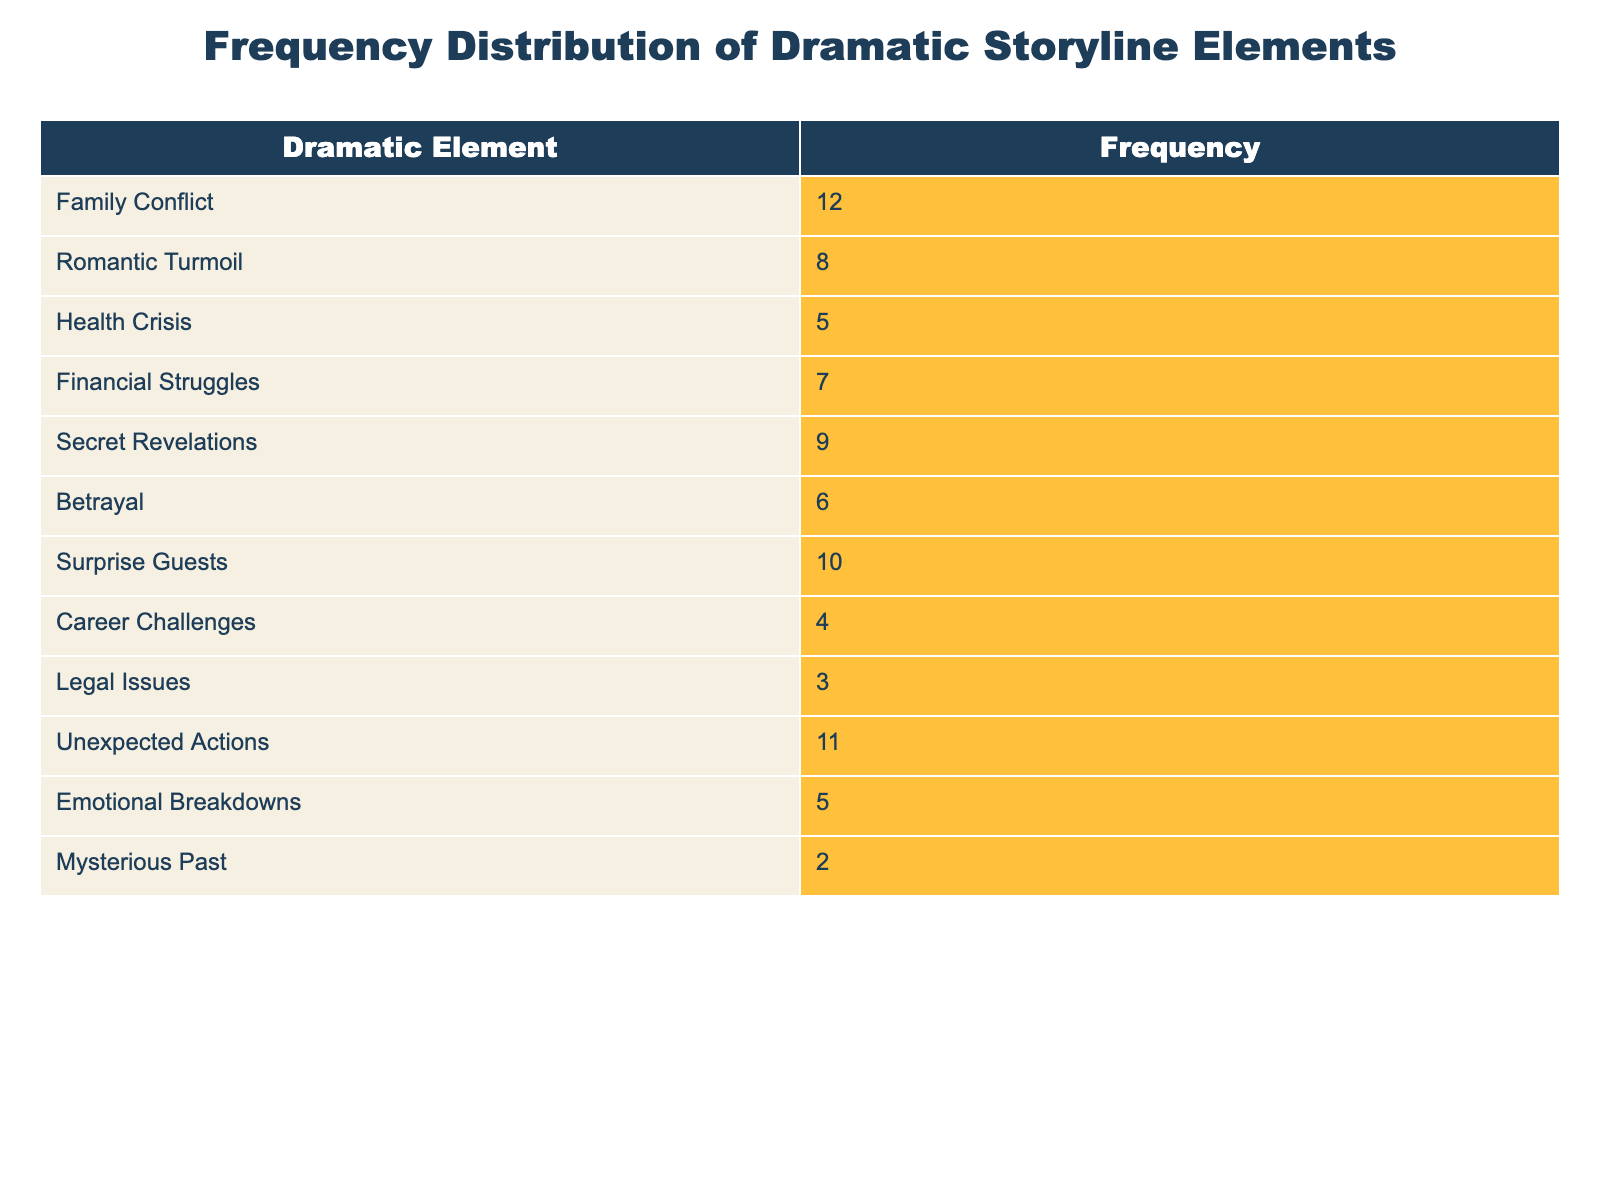What is the frequency of Family Conflict? It is directly mentioned in the table under the Dramatic Element 'Family Conflict', which shows a frequency of 12.
Answer: 12 What is the total frequency of Romantic Turmoil and Health Crisis? The frequency of Romantic Turmoil is 8 and the frequency of Health Crisis is 5. Adding them together gives us 8 + 5 = 13.
Answer: 13 Is the frequency of Legal Issues greater than that of Career Challenges? The table shows that the frequency of Legal Issues is 3 and the frequency of Career Challenges is 4. Since 3 is less than 4, the answer is no.
Answer: No Which dramatic element has the highest frequency? By reviewing the frequencies listed, Family Conflict has the highest frequency of 12 compared to the other elements.
Answer: Family Conflict What is the average frequency of all dramatic elements? To find the average, sum all the frequencies: 12 + 8 + 5 + 7 + 9 + 6 + 10 + 4 + 3 + 11 + 5 + 2 = 82. There are 12 elements, so we divide 82 by 12, which gives us approximately 6.83.
Answer: 6.83 How many dramatic elements have a frequency of 6 or higher? The elements with frequencies of 6 or higher are Family Conflict (12), Surprise Guests (10), Unexpected Actions (11), Secret Revelations (9), Romantic Turmoil (8), and Financial Struggles (7). Counting these gives us a total of 6 elements.
Answer: 6 What is the difference in frequency between the element with the highest and the element with the lowest frequency? The highest frequency is Family Conflict with 12, and the lowest frequency is Mysterious Past with 2. The difference is 12 - 2 = 10.
Answer: 10 Is there a greater frequency of Emotional Breakdowns or Financial Struggles? Emotional Breakdowns has a frequency of 5, while Financial Struggles has a frequency of 7. Since 5 is less than 7, the answer is no.
Answer: No What percentage of the total frequency does Surprise Guests represent? First, calculate the total frequency, which is 82. The frequency of Surprise Guests is 10. The percentage is calculated as (10/82) * 100, which equals approximately 12.2%.
Answer: 12.2% 